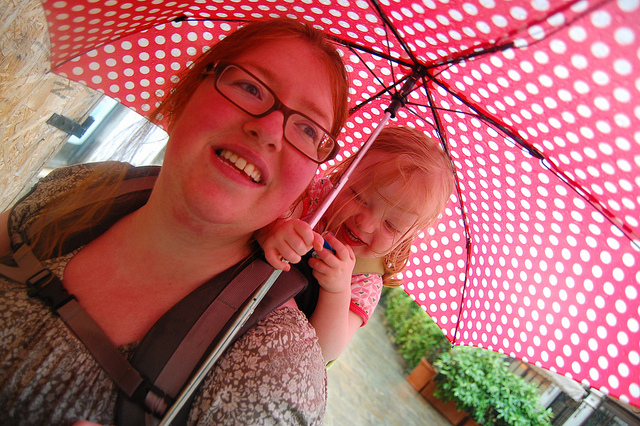Identify the text contained in this image. z 